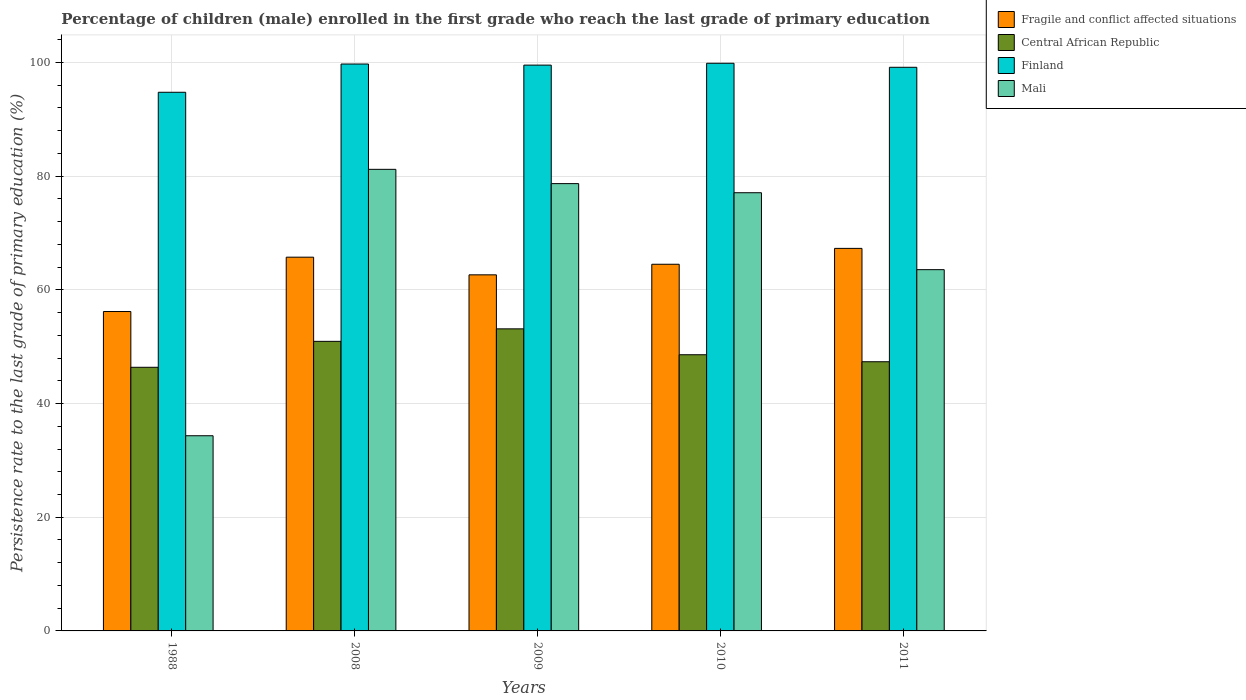How many different coloured bars are there?
Provide a succinct answer. 4. Are the number of bars per tick equal to the number of legend labels?
Ensure brevity in your answer.  Yes. Are the number of bars on each tick of the X-axis equal?
Offer a terse response. Yes. How many bars are there on the 4th tick from the left?
Provide a succinct answer. 4. What is the persistence rate of children in Finland in 2010?
Offer a terse response. 99.85. Across all years, what is the maximum persistence rate of children in Finland?
Offer a terse response. 99.85. Across all years, what is the minimum persistence rate of children in Finland?
Your answer should be compact. 94.75. In which year was the persistence rate of children in Central African Republic minimum?
Your answer should be very brief. 1988. What is the total persistence rate of children in Central African Republic in the graph?
Keep it short and to the point. 246.37. What is the difference between the persistence rate of children in Central African Republic in 1988 and that in 2009?
Offer a very short reply. -6.76. What is the difference between the persistence rate of children in Central African Republic in 1988 and the persistence rate of children in Finland in 2008?
Offer a very short reply. -53.35. What is the average persistence rate of children in Fragile and conflict affected situations per year?
Ensure brevity in your answer.  63.27. In the year 1988, what is the difference between the persistence rate of children in Mali and persistence rate of children in Central African Republic?
Your answer should be compact. -12.04. In how many years, is the persistence rate of children in Central African Republic greater than 48 %?
Give a very brief answer. 3. What is the ratio of the persistence rate of children in Mali in 2008 to that in 2011?
Give a very brief answer. 1.28. Is the difference between the persistence rate of children in Mali in 2010 and 2011 greater than the difference between the persistence rate of children in Central African Republic in 2010 and 2011?
Keep it short and to the point. Yes. What is the difference between the highest and the second highest persistence rate of children in Central African Republic?
Keep it short and to the point. 2.2. What is the difference between the highest and the lowest persistence rate of children in Fragile and conflict affected situations?
Keep it short and to the point. 11.11. In how many years, is the persistence rate of children in Mali greater than the average persistence rate of children in Mali taken over all years?
Make the answer very short. 3. Is the sum of the persistence rate of children in Finland in 2008 and 2009 greater than the maximum persistence rate of children in Central African Republic across all years?
Your response must be concise. Yes. Is it the case that in every year, the sum of the persistence rate of children in Mali and persistence rate of children in Fragile and conflict affected situations is greater than the sum of persistence rate of children in Central African Republic and persistence rate of children in Finland?
Your answer should be very brief. No. What does the 2nd bar from the left in 2008 represents?
Your response must be concise. Central African Republic. What does the 2nd bar from the right in 2009 represents?
Give a very brief answer. Finland. Are all the bars in the graph horizontal?
Keep it short and to the point. No. How many years are there in the graph?
Your answer should be very brief. 5. Are the values on the major ticks of Y-axis written in scientific E-notation?
Give a very brief answer. No. How many legend labels are there?
Keep it short and to the point. 4. What is the title of the graph?
Make the answer very short. Percentage of children (male) enrolled in the first grade who reach the last grade of primary education. What is the label or title of the Y-axis?
Ensure brevity in your answer.  Persistence rate to the last grade of primary education (%). What is the Persistence rate to the last grade of primary education (%) of Fragile and conflict affected situations in 1988?
Keep it short and to the point. 56.18. What is the Persistence rate to the last grade of primary education (%) of Central African Republic in 1988?
Offer a very short reply. 46.37. What is the Persistence rate to the last grade of primary education (%) of Finland in 1988?
Make the answer very short. 94.75. What is the Persistence rate to the last grade of primary education (%) in Mali in 1988?
Offer a very short reply. 34.33. What is the Persistence rate to the last grade of primary education (%) in Fragile and conflict affected situations in 2008?
Provide a short and direct response. 65.74. What is the Persistence rate to the last grade of primary education (%) of Central African Republic in 2008?
Offer a terse response. 50.94. What is the Persistence rate to the last grade of primary education (%) in Finland in 2008?
Offer a very short reply. 99.72. What is the Persistence rate to the last grade of primary education (%) in Mali in 2008?
Your response must be concise. 81.19. What is the Persistence rate to the last grade of primary education (%) in Fragile and conflict affected situations in 2009?
Make the answer very short. 62.64. What is the Persistence rate to the last grade of primary education (%) in Central African Republic in 2009?
Your answer should be compact. 53.13. What is the Persistence rate to the last grade of primary education (%) of Finland in 2009?
Keep it short and to the point. 99.53. What is the Persistence rate to the last grade of primary education (%) of Mali in 2009?
Keep it short and to the point. 78.68. What is the Persistence rate to the last grade of primary education (%) in Fragile and conflict affected situations in 2010?
Your response must be concise. 64.5. What is the Persistence rate to the last grade of primary education (%) in Central African Republic in 2010?
Offer a very short reply. 48.58. What is the Persistence rate to the last grade of primary education (%) in Finland in 2010?
Your answer should be very brief. 99.85. What is the Persistence rate to the last grade of primary education (%) in Mali in 2010?
Provide a succinct answer. 77.08. What is the Persistence rate to the last grade of primary education (%) of Fragile and conflict affected situations in 2011?
Your response must be concise. 67.29. What is the Persistence rate to the last grade of primary education (%) in Central African Republic in 2011?
Ensure brevity in your answer.  47.35. What is the Persistence rate to the last grade of primary education (%) of Finland in 2011?
Keep it short and to the point. 99.14. What is the Persistence rate to the last grade of primary education (%) in Mali in 2011?
Provide a short and direct response. 63.55. Across all years, what is the maximum Persistence rate to the last grade of primary education (%) in Fragile and conflict affected situations?
Provide a succinct answer. 67.29. Across all years, what is the maximum Persistence rate to the last grade of primary education (%) of Central African Republic?
Offer a terse response. 53.13. Across all years, what is the maximum Persistence rate to the last grade of primary education (%) in Finland?
Ensure brevity in your answer.  99.85. Across all years, what is the maximum Persistence rate to the last grade of primary education (%) in Mali?
Make the answer very short. 81.19. Across all years, what is the minimum Persistence rate to the last grade of primary education (%) of Fragile and conflict affected situations?
Keep it short and to the point. 56.18. Across all years, what is the minimum Persistence rate to the last grade of primary education (%) in Central African Republic?
Your response must be concise. 46.37. Across all years, what is the minimum Persistence rate to the last grade of primary education (%) in Finland?
Keep it short and to the point. 94.75. Across all years, what is the minimum Persistence rate to the last grade of primary education (%) in Mali?
Your answer should be compact. 34.33. What is the total Persistence rate to the last grade of primary education (%) of Fragile and conflict affected situations in the graph?
Give a very brief answer. 316.35. What is the total Persistence rate to the last grade of primary education (%) in Central African Republic in the graph?
Keep it short and to the point. 246.37. What is the total Persistence rate to the last grade of primary education (%) in Finland in the graph?
Your answer should be compact. 492.99. What is the total Persistence rate to the last grade of primary education (%) of Mali in the graph?
Provide a short and direct response. 334.83. What is the difference between the Persistence rate to the last grade of primary education (%) of Fragile and conflict affected situations in 1988 and that in 2008?
Your response must be concise. -9.56. What is the difference between the Persistence rate to the last grade of primary education (%) of Central African Republic in 1988 and that in 2008?
Provide a short and direct response. -4.56. What is the difference between the Persistence rate to the last grade of primary education (%) in Finland in 1988 and that in 2008?
Provide a succinct answer. -4.97. What is the difference between the Persistence rate to the last grade of primary education (%) in Mali in 1988 and that in 2008?
Offer a very short reply. -46.86. What is the difference between the Persistence rate to the last grade of primary education (%) in Fragile and conflict affected situations in 1988 and that in 2009?
Provide a succinct answer. -6.45. What is the difference between the Persistence rate to the last grade of primary education (%) in Central African Republic in 1988 and that in 2009?
Your answer should be very brief. -6.76. What is the difference between the Persistence rate to the last grade of primary education (%) of Finland in 1988 and that in 2009?
Your answer should be very brief. -4.78. What is the difference between the Persistence rate to the last grade of primary education (%) in Mali in 1988 and that in 2009?
Offer a terse response. -44.35. What is the difference between the Persistence rate to the last grade of primary education (%) of Fragile and conflict affected situations in 1988 and that in 2010?
Ensure brevity in your answer.  -8.32. What is the difference between the Persistence rate to the last grade of primary education (%) of Central African Republic in 1988 and that in 2010?
Your response must be concise. -2.21. What is the difference between the Persistence rate to the last grade of primary education (%) in Finland in 1988 and that in 2010?
Make the answer very short. -5.1. What is the difference between the Persistence rate to the last grade of primary education (%) of Mali in 1988 and that in 2010?
Your response must be concise. -42.75. What is the difference between the Persistence rate to the last grade of primary education (%) of Fragile and conflict affected situations in 1988 and that in 2011?
Your response must be concise. -11.11. What is the difference between the Persistence rate to the last grade of primary education (%) of Central African Republic in 1988 and that in 2011?
Make the answer very short. -0.98. What is the difference between the Persistence rate to the last grade of primary education (%) in Finland in 1988 and that in 2011?
Keep it short and to the point. -4.39. What is the difference between the Persistence rate to the last grade of primary education (%) in Mali in 1988 and that in 2011?
Make the answer very short. -29.21. What is the difference between the Persistence rate to the last grade of primary education (%) of Fragile and conflict affected situations in 2008 and that in 2009?
Offer a very short reply. 3.11. What is the difference between the Persistence rate to the last grade of primary education (%) of Central African Republic in 2008 and that in 2009?
Provide a short and direct response. -2.2. What is the difference between the Persistence rate to the last grade of primary education (%) in Finland in 2008 and that in 2009?
Your answer should be very brief. 0.19. What is the difference between the Persistence rate to the last grade of primary education (%) in Mali in 2008 and that in 2009?
Make the answer very short. 2.51. What is the difference between the Persistence rate to the last grade of primary education (%) of Fragile and conflict affected situations in 2008 and that in 2010?
Offer a very short reply. 1.24. What is the difference between the Persistence rate to the last grade of primary education (%) of Central African Republic in 2008 and that in 2010?
Provide a succinct answer. 2.36. What is the difference between the Persistence rate to the last grade of primary education (%) of Finland in 2008 and that in 2010?
Your answer should be compact. -0.14. What is the difference between the Persistence rate to the last grade of primary education (%) in Mali in 2008 and that in 2010?
Offer a terse response. 4.11. What is the difference between the Persistence rate to the last grade of primary education (%) of Fragile and conflict affected situations in 2008 and that in 2011?
Give a very brief answer. -1.55. What is the difference between the Persistence rate to the last grade of primary education (%) of Central African Republic in 2008 and that in 2011?
Ensure brevity in your answer.  3.59. What is the difference between the Persistence rate to the last grade of primary education (%) in Finland in 2008 and that in 2011?
Your response must be concise. 0.57. What is the difference between the Persistence rate to the last grade of primary education (%) in Mali in 2008 and that in 2011?
Ensure brevity in your answer.  17.65. What is the difference between the Persistence rate to the last grade of primary education (%) in Fragile and conflict affected situations in 2009 and that in 2010?
Ensure brevity in your answer.  -1.86. What is the difference between the Persistence rate to the last grade of primary education (%) of Central African Republic in 2009 and that in 2010?
Ensure brevity in your answer.  4.55. What is the difference between the Persistence rate to the last grade of primary education (%) in Finland in 2009 and that in 2010?
Provide a short and direct response. -0.33. What is the difference between the Persistence rate to the last grade of primary education (%) in Mali in 2009 and that in 2010?
Ensure brevity in your answer.  1.6. What is the difference between the Persistence rate to the last grade of primary education (%) of Fragile and conflict affected situations in 2009 and that in 2011?
Offer a very short reply. -4.65. What is the difference between the Persistence rate to the last grade of primary education (%) of Central African Republic in 2009 and that in 2011?
Give a very brief answer. 5.79. What is the difference between the Persistence rate to the last grade of primary education (%) of Finland in 2009 and that in 2011?
Provide a succinct answer. 0.38. What is the difference between the Persistence rate to the last grade of primary education (%) in Mali in 2009 and that in 2011?
Give a very brief answer. 15.14. What is the difference between the Persistence rate to the last grade of primary education (%) of Fragile and conflict affected situations in 2010 and that in 2011?
Give a very brief answer. -2.79. What is the difference between the Persistence rate to the last grade of primary education (%) in Central African Republic in 2010 and that in 2011?
Your answer should be very brief. 1.23. What is the difference between the Persistence rate to the last grade of primary education (%) of Finland in 2010 and that in 2011?
Your answer should be very brief. 0.71. What is the difference between the Persistence rate to the last grade of primary education (%) in Mali in 2010 and that in 2011?
Give a very brief answer. 13.53. What is the difference between the Persistence rate to the last grade of primary education (%) in Fragile and conflict affected situations in 1988 and the Persistence rate to the last grade of primary education (%) in Central African Republic in 2008?
Give a very brief answer. 5.25. What is the difference between the Persistence rate to the last grade of primary education (%) in Fragile and conflict affected situations in 1988 and the Persistence rate to the last grade of primary education (%) in Finland in 2008?
Offer a terse response. -43.53. What is the difference between the Persistence rate to the last grade of primary education (%) of Fragile and conflict affected situations in 1988 and the Persistence rate to the last grade of primary education (%) of Mali in 2008?
Provide a short and direct response. -25.01. What is the difference between the Persistence rate to the last grade of primary education (%) of Central African Republic in 1988 and the Persistence rate to the last grade of primary education (%) of Finland in 2008?
Your answer should be very brief. -53.35. What is the difference between the Persistence rate to the last grade of primary education (%) in Central African Republic in 1988 and the Persistence rate to the last grade of primary education (%) in Mali in 2008?
Your answer should be very brief. -34.82. What is the difference between the Persistence rate to the last grade of primary education (%) of Finland in 1988 and the Persistence rate to the last grade of primary education (%) of Mali in 2008?
Your answer should be very brief. 13.56. What is the difference between the Persistence rate to the last grade of primary education (%) in Fragile and conflict affected situations in 1988 and the Persistence rate to the last grade of primary education (%) in Central African Republic in 2009?
Ensure brevity in your answer.  3.05. What is the difference between the Persistence rate to the last grade of primary education (%) in Fragile and conflict affected situations in 1988 and the Persistence rate to the last grade of primary education (%) in Finland in 2009?
Make the answer very short. -43.34. What is the difference between the Persistence rate to the last grade of primary education (%) in Fragile and conflict affected situations in 1988 and the Persistence rate to the last grade of primary education (%) in Mali in 2009?
Make the answer very short. -22.5. What is the difference between the Persistence rate to the last grade of primary education (%) in Central African Republic in 1988 and the Persistence rate to the last grade of primary education (%) in Finland in 2009?
Your answer should be very brief. -53.15. What is the difference between the Persistence rate to the last grade of primary education (%) of Central African Republic in 1988 and the Persistence rate to the last grade of primary education (%) of Mali in 2009?
Your response must be concise. -32.31. What is the difference between the Persistence rate to the last grade of primary education (%) of Finland in 1988 and the Persistence rate to the last grade of primary education (%) of Mali in 2009?
Make the answer very short. 16.07. What is the difference between the Persistence rate to the last grade of primary education (%) in Fragile and conflict affected situations in 1988 and the Persistence rate to the last grade of primary education (%) in Central African Republic in 2010?
Your answer should be very brief. 7.6. What is the difference between the Persistence rate to the last grade of primary education (%) in Fragile and conflict affected situations in 1988 and the Persistence rate to the last grade of primary education (%) in Finland in 2010?
Give a very brief answer. -43.67. What is the difference between the Persistence rate to the last grade of primary education (%) of Fragile and conflict affected situations in 1988 and the Persistence rate to the last grade of primary education (%) of Mali in 2010?
Your answer should be compact. -20.9. What is the difference between the Persistence rate to the last grade of primary education (%) in Central African Republic in 1988 and the Persistence rate to the last grade of primary education (%) in Finland in 2010?
Provide a succinct answer. -53.48. What is the difference between the Persistence rate to the last grade of primary education (%) in Central African Republic in 1988 and the Persistence rate to the last grade of primary education (%) in Mali in 2010?
Offer a very short reply. -30.71. What is the difference between the Persistence rate to the last grade of primary education (%) of Finland in 1988 and the Persistence rate to the last grade of primary education (%) of Mali in 2010?
Provide a short and direct response. 17.67. What is the difference between the Persistence rate to the last grade of primary education (%) in Fragile and conflict affected situations in 1988 and the Persistence rate to the last grade of primary education (%) in Central African Republic in 2011?
Your response must be concise. 8.83. What is the difference between the Persistence rate to the last grade of primary education (%) of Fragile and conflict affected situations in 1988 and the Persistence rate to the last grade of primary education (%) of Finland in 2011?
Keep it short and to the point. -42.96. What is the difference between the Persistence rate to the last grade of primary education (%) in Fragile and conflict affected situations in 1988 and the Persistence rate to the last grade of primary education (%) in Mali in 2011?
Give a very brief answer. -7.36. What is the difference between the Persistence rate to the last grade of primary education (%) of Central African Republic in 1988 and the Persistence rate to the last grade of primary education (%) of Finland in 2011?
Offer a terse response. -52.77. What is the difference between the Persistence rate to the last grade of primary education (%) in Central African Republic in 1988 and the Persistence rate to the last grade of primary education (%) in Mali in 2011?
Your answer should be very brief. -17.17. What is the difference between the Persistence rate to the last grade of primary education (%) in Finland in 1988 and the Persistence rate to the last grade of primary education (%) in Mali in 2011?
Offer a terse response. 31.2. What is the difference between the Persistence rate to the last grade of primary education (%) in Fragile and conflict affected situations in 2008 and the Persistence rate to the last grade of primary education (%) in Central African Republic in 2009?
Ensure brevity in your answer.  12.61. What is the difference between the Persistence rate to the last grade of primary education (%) in Fragile and conflict affected situations in 2008 and the Persistence rate to the last grade of primary education (%) in Finland in 2009?
Offer a very short reply. -33.78. What is the difference between the Persistence rate to the last grade of primary education (%) of Fragile and conflict affected situations in 2008 and the Persistence rate to the last grade of primary education (%) of Mali in 2009?
Your response must be concise. -12.94. What is the difference between the Persistence rate to the last grade of primary education (%) of Central African Republic in 2008 and the Persistence rate to the last grade of primary education (%) of Finland in 2009?
Offer a terse response. -48.59. What is the difference between the Persistence rate to the last grade of primary education (%) of Central African Republic in 2008 and the Persistence rate to the last grade of primary education (%) of Mali in 2009?
Make the answer very short. -27.75. What is the difference between the Persistence rate to the last grade of primary education (%) of Finland in 2008 and the Persistence rate to the last grade of primary education (%) of Mali in 2009?
Provide a succinct answer. 21.03. What is the difference between the Persistence rate to the last grade of primary education (%) of Fragile and conflict affected situations in 2008 and the Persistence rate to the last grade of primary education (%) of Central African Republic in 2010?
Ensure brevity in your answer.  17.16. What is the difference between the Persistence rate to the last grade of primary education (%) in Fragile and conflict affected situations in 2008 and the Persistence rate to the last grade of primary education (%) in Finland in 2010?
Ensure brevity in your answer.  -34.11. What is the difference between the Persistence rate to the last grade of primary education (%) of Fragile and conflict affected situations in 2008 and the Persistence rate to the last grade of primary education (%) of Mali in 2010?
Provide a succinct answer. -11.34. What is the difference between the Persistence rate to the last grade of primary education (%) of Central African Republic in 2008 and the Persistence rate to the last grade of primary education (%) of Finland in 2010?
Offer a terse response. -48.92. What is the difference between the Persistence rate to the last grade of primary education (%) of Central African Republic in 2008 and the Persistence rate to the last grade of primary education (%) of Mali in 2010?
Your answer should be compact. -26.14. What is the difference between the Persistence rate to the last grade of primary education (%) of Finland in 2008 and the Persistence rate to the last grade of primary education (%) of Mali in 2010?
Provide a short and direct response. 22.64. What is the difference between the Persistence rate to the last grade of primary education (%) in Fragile and conflict affected situations in 2008 and the Persistence rate to the last grade of primary education (%) in Central African Republic in 2011?
Offer a very short reply. 18.39. What is the difference between the Persistence rate to the last grade of primary education (%) in Fragile and conflict affected situations in 2008 and the Persistence rate to the last grade of primary education (%) in Finland in 2011?
Your answer should be very brief. -33.4. What is the difference between the Persistence rate to the last grade of primary education (%) of Fragile and conflict affected situations in 2008 and the Persistence rate to the last grade of primary education (%) of Mali in 2011?
Make the answer very short. 2.2. What is the difference between the Persistence rate to the last grade of primary education (%) in Central African Republic in 2008 and the Persistence rate to the last grade of primary education (%) in Finland in 2011?
Keep it short and to the point. -48.21. What is the difference between the Persistence rate to the last grade of primary education (%) of Central African Republic in 2008 and the Persistence rate to the last grade of primary education (%) of Mali in 2011?
Your response must be concise. -12.61. What is the difference between the Persistence rate to the last grade of primary education (%) in Finland in 2008 and the Persistence rate to the last grade of primary education (%) in Mali in 2011?
Give a very brief answer. 36.17. What is the difference between the Persistence rate to the last grade of primary education (%) in Fragile and conflict affected situations in 2009 and the Persistence rate to the last grade of primary education (%) in Central African Republic in 2010?
Offer a terse response. 14.06. What is the difference between the Persistence rate to the last grade of primary education (%) of Fragile and conflict affected situations in 2009 and the Persistence rate to the last grade of primary education (%) of Finland in 2010?
Your response must be concise. -37.22. What is the difference between the Persistence rate to the last grade of primary education (%) in Fragile and conflict affected situations in 2009 and the Persistence rate to the last grade of primary education (%) in Mali in 2010?
Your response must be concise. -14.44. What is the difference between the Persistence rate to the last grade of primary education (%) of Central African Republic in 2009 and the Persistence rate to the last grade of primary education (%) of Finland in 2010?
Your answer should be compact. -46.72. What is the difference between the Persistence rate to the last grade of primary education (%) in Central African Republic in 2009 and the Persistence rate to the last grade of primary education (%) in Mali in 2010?
Offer a terse response. -23.94. What is the difference between the Persistence rate to the last grade of primary education (%) of Finland in 2009 and the Persistence rate to the last grade of primary education (%) of Mali in 2010?
Give a very brief answer. 22.45. What is the difference between the Persistence rate to the last grade of primary education (%) of Fragile and conflict affected situations in 2009 and the Persistence rate to the last grade of primary education (%) of Central African Republic in 2011?
Your answer should be very brief. 15.29. What is the difference between the Persistence rate to the last grade of primary education (%) in Fragile and conflict affected situations in 2009 and the Persistence rate to the last grade of primary education (%) in Finland in 2011?
Your response must be concise. -36.51. What is the difference between the Persistence rate to the last grade of primary education (%) of Fragile and conflict affected situations in 2009 and the Persistence rate to the last grade of primary education (%) of Mali in 2011?
Your answer should be very brief. -0.91. What is the difference between the Persistence rate to the last grade of primary education (%) in Central African Republic in 2009 and the Persistence rate to the last grade of primary education (%) in Finland in 2011?
Keep it short and to the point. -46.01. What is the difference between the Persistence rate to the last grade of primary education (%) of Central African Republic in 2009 and the Persistence rate to the last grade of primary education (%) of Mali in 2011?
Ensure brevity in your answer.  -10.41. What is the difference between the Persistence rate to the last grade of primary education (%) of Finland in 2009 and the Persistence rate to the last grade of primary education (%) of Mali in 2011?
Your answer should be compact. 35.98. What is the difference between the Persistence rate to the last grade of primary education (%) in Fragile and conflict affected situations in 2010 and the Persistence rate to the last grade of primary education (%) in Central African Republic in 2011?
Offer a terse response. 17.15. What is the difference between the Persistence rate to the last grade of primary education (%) in Fragile and conflict affected situations in 2010 and the Persistence rate to the last grade of primary education (%) in Finland in 2011?
Give a very brief answer. -34.64. What is the difference between the Persistence rate to the last grade of primary education (%) of Fragile and conflict affected situations in 2010 and the Persistence rate to the last grade of primary education (%) of Mali in 2011?
Offer a terse response. 0.95. What is the difference between the Persistence rate to the last grade of primary education (%) in Central African Republic in 2010 and the Persistence rate to the last grade of primary education (%) in Finland in 2011?
Provide a short and direct response. -50.56. What is the difference between the Persistence rate to the last grade of primary education (%) in Central African Republic in 2010 and the Persistence rate to the last grade of primary education (%) in Mali in 2011?
Make the answer very short. -14.97. What is the difference between the Persistence rate to the last grade of primary education (%) of Finland in 2010 and the Persistence rate to the last grade of primary education (%) of Mali in 2011?
Give a very brief answer. 36.31. What is the average Persistence rate to the last grade of primary education (%) of Fragile and conflict affected situations per year?
Give a very brief answer. 63.27. What is the average Persistence rate to the last grade of primary education (%) of Central African Republic per year?
Give a very brief answer. 49.27. What is the average Persistence rate to the last grade of primary education (%) in Finland per year?
Offer a terse response. 98.6. What is the average Persistence rate to the last grade of primary education (%) in Mali per year?
Provide a succinct answer. 66.97. In the year 1988, what is the difference between the Persistence rate to the last grade of primary education (%) of Fragile and conflict affected situations and Persistence rate to the last grade of primary education (%) of Central African Republic?
Give a very brief answer. 9.81. In the year 1988, what is the difference between the Persistence rate to the last grade of primary education (%) in Fragile and conflict affected situations and Persistence rate to the last grade of primary education (%) in Finland?
Your answer should be very brief. -38.57. In the year 1988, what is the difference between the Persistence rate to the last grade of primary education (%) of Fragile and conflict affected situations and Persistence rate to the last grade of primary education (%) of Mali?
Provide a succinct answer. 21.85. In the year 1988, what is the difference between the Persistence rate to the last grade of primary education (%) of Central African Republic and Persistence rate to the last grade of primary education (%) of Finland?
Ensure brevity in your answer.  -48.38. In the year 1988, what is the difference between the Persistence rate to the last grade of primary education (%) in Central African Republic and Persistence rate to the last grade of primary education (%) in Mali?
Offer a very short reply. 12.04. In the year 1988, what is the difference between the Persistence rate to the last grade of primary education (%) in Finland and Persistence rate to the last grade of primary education (%) in Mali?
Keep it short and to the point. 60.42. In the year 2008, what is the difference between the Persistence rate to the last grade of primary education (%) in Fragile and conflict affected situations and Persistence rate to the last grade of primary education (%) in Central African Republic?
Your response must be concise. 14.8. In the year 2008, what is the difference between the Persistence rate to the last grade of primary education (%) in Fragile and conflict affected situations and Persistence rate to the last grade of primary education (%) in Finland?
Offer a very short reply. -33.98. In the year 2008, what is the difference between the Persistence rate to the last grade of primary education (%) of Fragile and conflict affected situations and Persistence rate to the last grade of primary education (%) of Mali?
Ensure brevity in your answer.  -15.45. In the year 2008, what is the difference between the Persistence rate to the last grade of primary education (%) of Central African Republic and Persistence rate to the last grade of primary education (%) of Finland?
Make the answer very short. -48.78. In the year 2008, what is the difference between the Persistence rate to the last grade of primary education (%) in Central African Republic and Persistence rate to the last grade of primary education (%) in Mali?
Your answer should be very brief. -30.26. In the year 2008, what is the difference between the Persistence rate to the last grade of primary education (%) of Finland and Persistence rate to the last grade of primary education (%) of Mali?
Offer a terse response. 18.52. In the year 2009, what is the difference between the Persistence rate to the last grade of primary education (%) of Fragile and conflict affected situations and Persistence rate to the last grade of primary education (%) of Central African Republic?
Your response must be concise. 9.5. In the year 2009, what is the difference between the Persistence rate to the last grade of primary education (%) of Fragile and conflict affected situations and Persistence rate to the last grade of primary education (%) of Finland?
Your response must be concise. -36.89. In the year 2009, what is the difference between the Persistence rate to the last grade of primary education (%) in Fragile and conflict affected situations and Persistence rate to the last grade of primary education (%) in Mali?
Your answer should be compact. -16.05. In the year 2009, what is the difference between the Persistence rate to the last grade of primary education (%) of Central African Republic and Persistence rate to the last grade of primary education (%) of Finland?
Your answer should be very brief. -46.39. In the year 2009, what is the difference between the Persistence rate to the last grade of primary education (%) in Central African Republic and Persistence rate to the last grade of primary education (%) in Mali?
Give a very brief answer. -25.55. In the year 2009, what is the difference between the Persistence rate to the last grade of primary education (%) of Finland and Persistence rate to the last grade of primary education (%) of Mali?
Offer a terse response. 20.84. In the year 2010, what is the difference between the Persistence rate to the last grade of primary education (%) of Fragile and conflict affected situations and Persistence rate to the last grade of primary education (%) of Central African Republic?
Your answer should be very brief. 15.92. In the year 2010, what is the difference between the Persistence rate to the last grade of primary education (%) of Fragile and conflict affected situations and Persistence rate to the last grade of primary education (%) of Finland?
Give a very brief answer. -35.36. In the year 2010, what is the difference between the Persistence rate to the last grade of primary education (%) of Fragile and conflict affected situations and Persistence rate to the last grade of primary education (%) of Mali?
Ensure brevity in your answer.  -12.58. In the year 2010, what is the difference between the Persistence rate to the last grade of primary education (%) in Central African Republic and Persistence rate to the last grade of primary education (%) in Finland?
Make the answer very short. -51.27. In the year 2010, what is the difference between the Persistence rate to the last grade of primary education (%) in Central African Republic and Persistence rate to the last grade of primary education (%) in Mali?
Your response must be concise. -28.5. In the year 2010, what is the difference between the Persistence rate to the last grade of primary education (%) in Finland and Persistence rate to the last grade of primary education (%) in Mali?
Ensure brevity in your answer.  22.77. In the year 2011, what is the difference between the Persistence rate to the last grade of primary education (%) in Fragile and conflict affected situations and Persistence rate to the last grade of primary education (%) in Central African Republic?
Provide a short and direct response. 19.94. In the year 2011, what is the difference between the Persistence rate to the last grade of primary education (%) of Fragile and conflict affected situations and Persistence rate to the last grade of primary education (%) of Finland?
Make the answer very short. -31.85. In the year 2011, what is the difference between the Persistence rate to the last grade of primary education (%) of Fragile and conflict affected situations and Persistence rate to the last grade of primary education (%) of Mali?
Your answer should be very brief. 3.74. In the year 2011, what is the difference between the Persistence rate to the last grade of primary education (%) of Central African Republic and Persistence rate to the last grade of primary education (%) of Finland?
Offer a terse response. -51.79. In the year 2011, what is the difference between the Persistence rate to the last grade of primary education (%) in Central African Republic and Persistence rate to the last grade of primary education (%) in Mali?
Offer a terse response. -16.2. In the year 2011, what is the difference between the Persistence rate to the last grade of primary education (%) in Finland and Persistence rate to the last grade of primary education (%) in Mali?
Provide a short and direct response. 35.6. What is the ratio of the Persistence rate to the last grade of primary education (%) of Fragile and conflict affected situations in 1988 to that in 2008?
Your answer should be compact. 0.85. What is the ratio of the Persistence rate to the last grade of primary education (%) of Central African Republic in 1988 to that in 2008?
Keep it short and to the point. 0.91. What is the ratio of the Persistence rate to the last grade of primary education (%) in Finland in 1988 to that in 2008?
Ensure brevity in your answer.  0.95. What is the ratio of the Persistence rate to the last grade of primary education (%) in Mali in 1988 to that in 2008?
Provide a short and direct response. 0.42. What is the ratio of the Persistence rate to the last grade of primary education (%) in Fragile and conflict affected situations in 1988 to that in 2009?
Give a very brief answer. 0.9. What is the ratio of the Persistence rate to the last grade of primary education (%) in Central African Republic in 1988 to that in 2009?
Provide a short and direct response. 0.87. What is the ratio of the Persistence rate to the last grade of primary education (%) in Mali in 1988 to that in 2009?
Provide a succinct answer. 0.44. What is the ratio of the Persistence rate to the last grade of primary education (%) of Fragile and conflict affected situations in 1988 to that in 2010?
Ensure brevity in your answer.  0.87. What is the ratio of the Persistence rate to the last grade of primary education (%) in Central African Republic in 1988 to that in 2010?
Provide a succinct answer. 0.95. What is the ratio of the Persistence rate to the last grade of primary education (%) in Finland in 1988 to that in 2010?
Provide a short and direct response. 0.95. What is the ratio of the Persistence rate to the last grade of primary education (%) of Mali in 1988 to that in 2010?
Provide a succinct answer. 0.45. What is the ratio of the Persistence rate to the last grade of primary education (%) of Fragile and conflict affected situations in 1988 to that in 2011?
Keep it short and to the point. 0.83. What is the ratio of the Persistence rate to the last grade of primary education (%) of Central African Republic in 1988 to that in 2011?
Your answer should be compact. 0.98. What is the ratio of the Persistence rate to the last grade of primary education (%) of Finland in 1988 to that in 2011?
Your answer should be compact. 0.96. What is the ratio of the Persistence rate to the last grade of primary education (%) in Mali in 1988 to that in 2011?
Make the answer very short. 0.54. What is the ratio of the Persistence rate to the last grade of primary education (%) of Fragile and conflict affected situations in 2008 to that in 2009?
Offer a terse response. 1.05. What is the ratio of the Persistence rate to the last grade of primary education (%) in Central African Republic in 2008 to that in 2009?
Give a very brief answer. 0.96. What is the ratio of the Persistence rate to the last grade of primary education (%) in Finland in 2008 to that in 2009?
Offer a terse response. 1. What is the ratio of the Persistence rate to the last grade of primary education (%) of Mali in 2008 to that in 2009?
Provide a succinct answer. 1.03. What is the ratio of the Persistence rate to the last grade of primary education (%) in Fragile and conflict affected situations in 2008 to that in 2010?
Ensure brevity in your answer.  1.02. What is the ratio of the Persistence rate to the last grade of primary education (%) of Central African Republic in 2008 to that in 2010?
Offer a very short reply. 1.05. What is the ratio of the Persistence rate to the last grade of primary education (%) of Finland in 2008 to that in 2010?
Provide a succinct answer. 1. What is the ratio of the Persistence rate to the last grade of primary education (%) in Mali in 2008 to that in 2010?
Offer a very short reply. 1.05. What is the ratio of the Persistence rate to the last grade of primary education (%) of Fragile and conflict affected situations in 2008 to that in 2011?
Your response must be concise. 0.98. What is the ratio of the Persistence rate to the last grade of primary education (%) of Central African Republic in 2008 to that in 2011?
Offer a very short reply. 1.08. What is the ratio of the Persistence rate to the last grade of primary education (%) of Finland in 2008 to that in 2011?
Give a very brief answer. 1.01. What is the ratio of the Persistence rate to the last grade of primary education (%) of Mali in 2008 to that in 2011?
Ensure brevity in your answer.  1.28. What is the ratio of the Persistence rate to the last grade of primary education (%) in Fragile and conflict affected situations in 2009 to that in 2010?
Provide a succinct answer. 0.97. What is the ratio of the Persistence rate to the last grade of primary education (%) of Central African Republic in 2009 to that in 2010?
Offer a terse response. 1.09. What is the ratio of the Persistence rate to the last grade of primary education (%) in Mali in 2009 to that in 2010?
Offer a terse response. 1.02. What is the ratio of the Persistence rate to the last grade of primary education (%) of Fragile and conflict affected situations in 2009 to that in 2011?
Offer a very short reply. 0.93. What is the ratio of the Persistence rate to the last grade of primary education (%) in Central African Republic in 2009 to that in 2011?
Make the answer very short. 1.12. What is the ratio of the Persistence rate to the last grade of primary education (%) in Mali in 2009 to that in 2011?
Provide a short and direct response. 1.24. What is the ratio of the Persistence rate to the last grade of primary education (%) in Fragile and conflict affected situations in 2010 to that in 2011?
Your answer should be very brief. 0.96. What is the ratio of the Persistence rate to the last grade of primary education (%) in Central African Republic in 2010 to that in 2011?
Offer a very short reply. 1.03. What is the ratio of the Persistence rate to the last grade of primary education (%) in Finland in 2010 to that in 2011?
Your response must be concise. 1.01. What is the ratio of the Persistence rate to the last grade of primary education (%) in Mali in 2010 to that in 2011?
Your response must be concise. 1.21. What is the difference between the highest and the second highest Persistence rate to the last grade of primary education (%) in Fragile and conflict affected situations?
Provide a succinct answer. 1.55. What is the difference between the highest and the second highest Persistence rate to the last grade of primary education (%) of Central African Republic?
Offer a terse response. 2.2. What is the difference between the highest and the second highest Persistence rate to the last grade of primary education (%) of Finland?
Keep it short and to the point. 0.14. What is the difference between the highest and the second highest Persistence rate to the last grade of primary education (%) in Mali?
Give a very brief answer. 2.51. What is the difference between the highest and the lowest Persistence rate to the last grade of primary education (%) of Fragile and conflict affected situations?
Provide a succinct answer. 11.11. What is the difference between the highest and the lowest Persistence rate to the last grade of primary education (%) of Central African Republic?
Provide a succinct answer. 6.76. What is the difference between the highest and the lowest Persistence rate to the last grade of primary education (%) of Finland?
Your answer should be very brief. 5.1. What is the difference between the highest and the lowest Persistence rate to the last grade of primary education (%) in Mali?
Your answer should be compact. 46.86. 